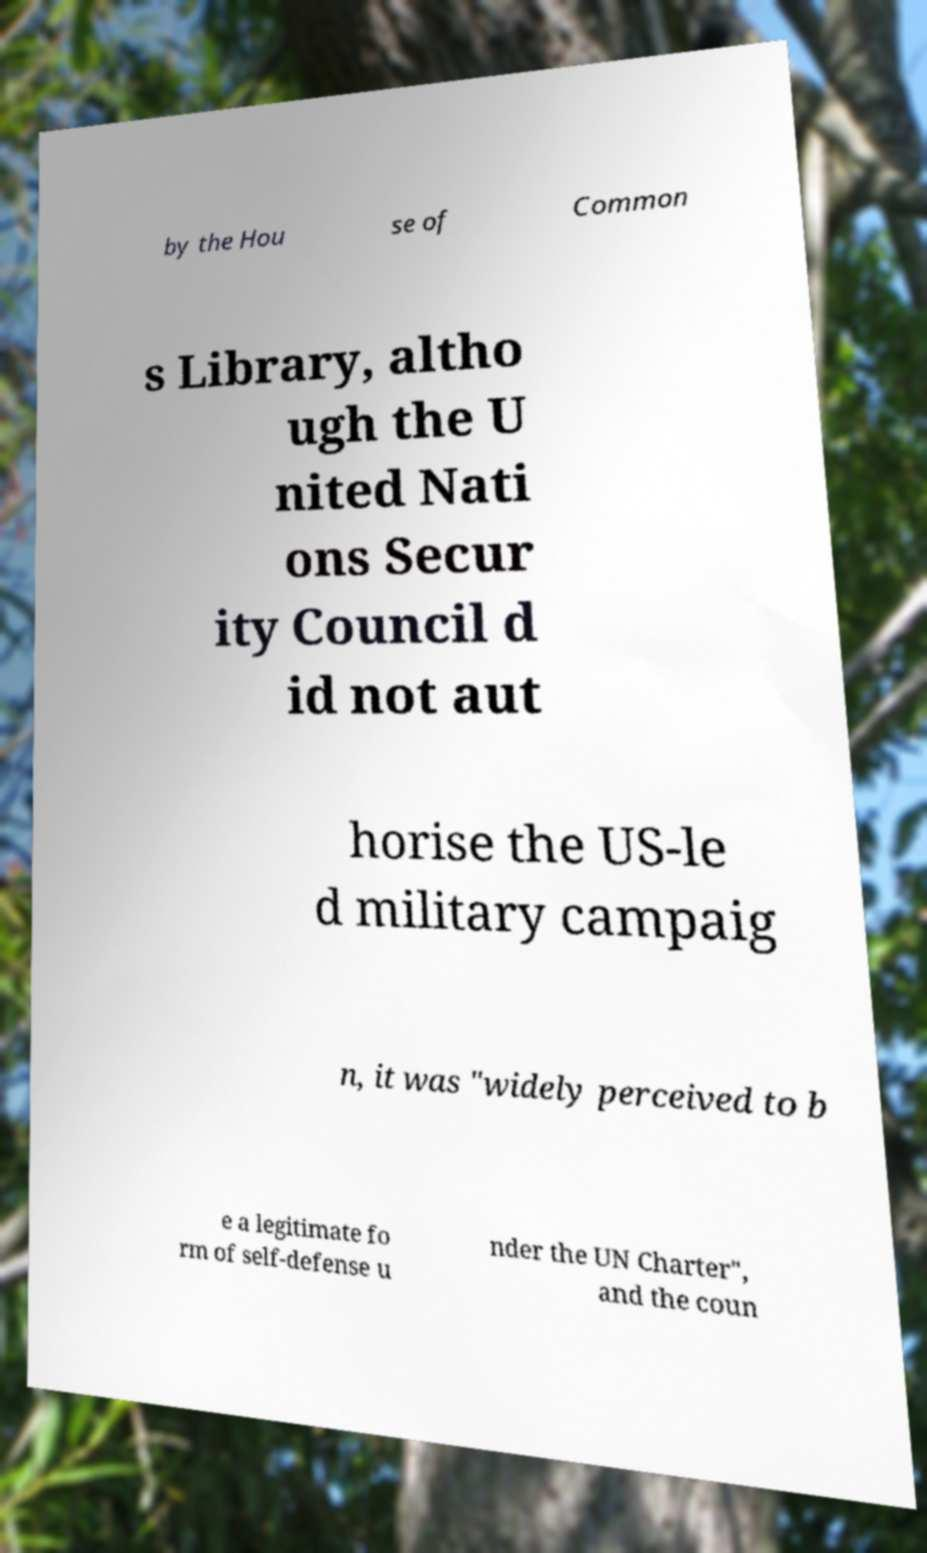There's text embedded in this image that I need extracted. Can you transcribe it verbatim? by the Hou se of Common s Library, altho ugh the U nited Nati ons Secur ity Council d id not aut horise the US-le d military campaig n, it was "widely perceived to b e a legitimate fo rm of self-defense u nder the UN Charter", and the coun 